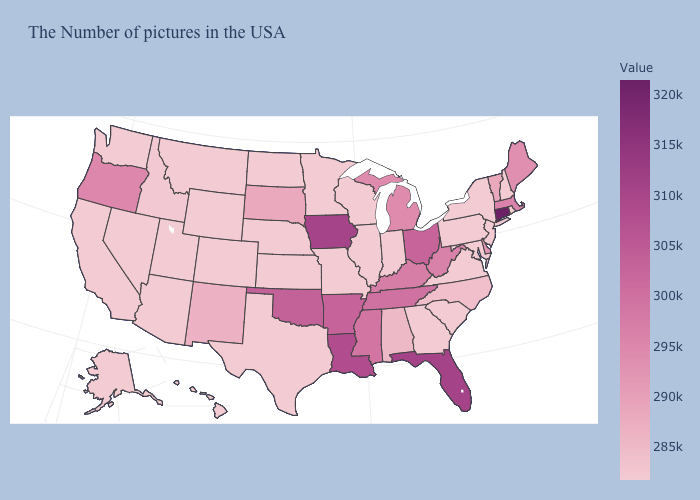Among the states that border Pennsylvania , which have the highest value?
Concise answer only. Ohio. Which states have the lowest value in the USA?
Answer briefly. Rhode Island, New Hampshire, New York, New Jersey, Maryland, Pennsylvania, Virginia, South Carolina, Georgia, Indiana, Wisconsin, Illinois, Missouri, Minnesota, Kansas, Nebraska, Texas, North Dakota, Wyoming, Colorado, Utah, Montana, Arizona, Nevada, California, Washington, Alaska, Hawaii. Does Kansas have the highest value in the USA?
Concise answer only. No. Which states have the lowest value in the USA?
Give a very brief answer. Rhode Island, New Hampshire, New York, New Jersey, Maryland, Pennsylvania, Virginia, South Carolina, Georgia, Indiana, Wisconsin, Illinois, Missouri, Minnesota, Kansas, Nebraska, Texas, North Dakota, Wyoming, Colorado, Utah, Montana, Arizona, Nevada, California, Washington, Alaska, Hawaii. Which states have the lowest value in the West?
Give a very brief answer. Wyoming, Colorado, Utah, Montana, Arizona, Nevada, California, Washington, Alaska, Hawaii. Does South Dakota have the lowest value in the USA?
Be succinct. No. 